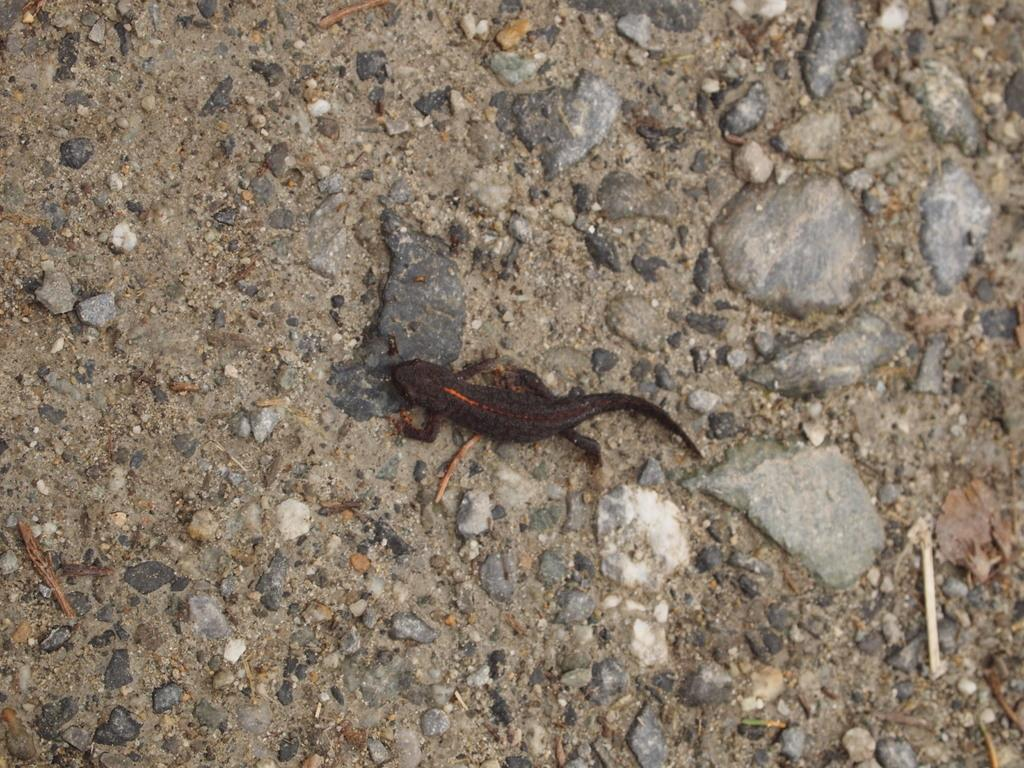What type of animal can be seen in the picture? There is a brown-colored lizard in the picture. What is the primary surface visible in the picture? There is ground visible in the picture. Are there any additional features on the ground? Yes, there are stones present on the ground. What type of apparatus is being used by the dad in the picture? There is no dad or apparatus present in the picture; it features a brown-colored lizard and stones on the ground. What type of furniture can be seen in the picture? There is no furniture present in the picture; it features a brown-colored lizard and stones on the ground. 